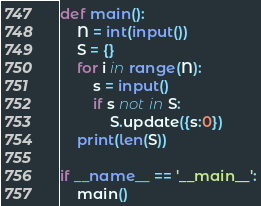<code> <loc_0><loc_0><loc_500><loc_500><_Python_>def main():
    N = int(input())
    S = {}
    for i in range(N):
        s = input()
        if s not in S:
            S.update({s:0})
    print(len(S))

if __name__ == '__main__':
    main()
</code> 